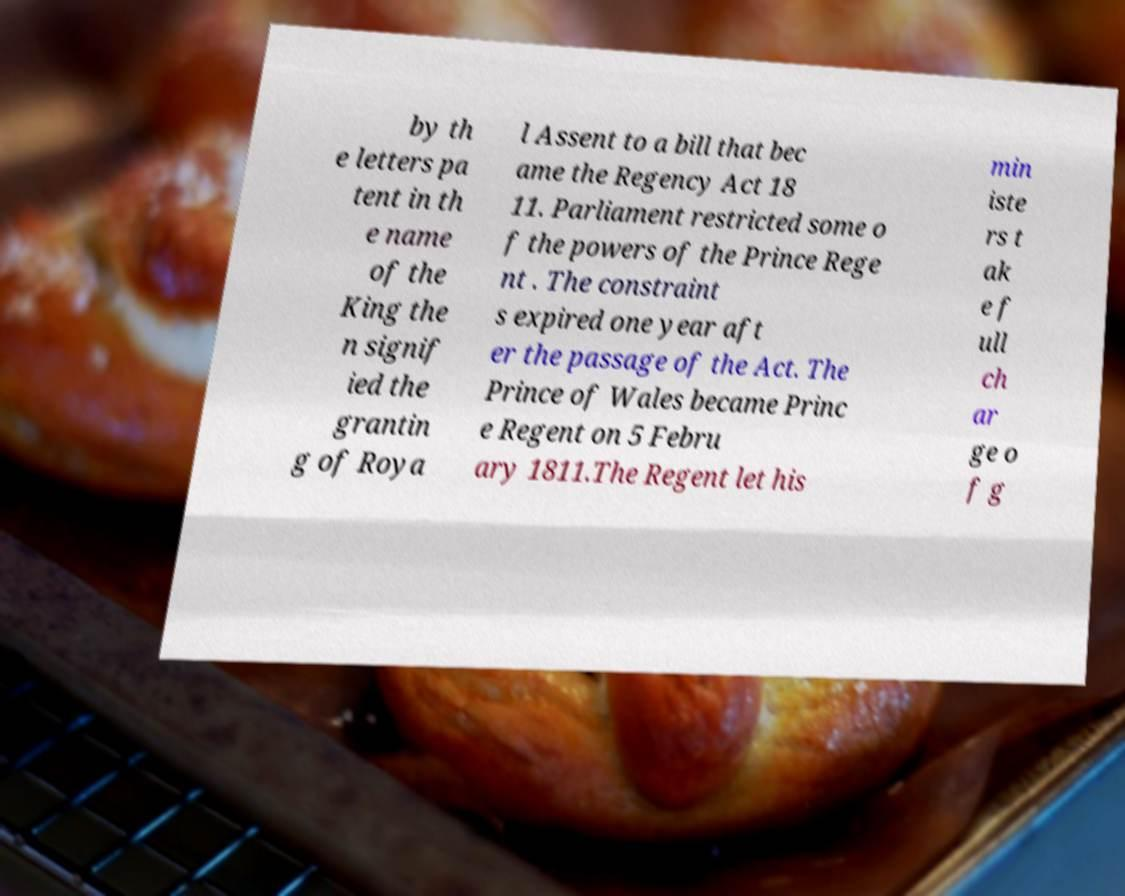What messages or text are displayed in this image? I need them in a readable, typed format. by th e letters pa tent in th e name of the King the n signif ied the grantin g of Roya l Assent to a bill that bec ame the Regency Act 18 11. Parliament restricted some o f the powers of the Prince Rege nt . The constraint s expired one year aft er the passage of the Act. The Prince of Wales became Princ e Regent on 5 Febru ary 1811.The Regent let his min iste rs t ak e f ull ch ar ge o f g 